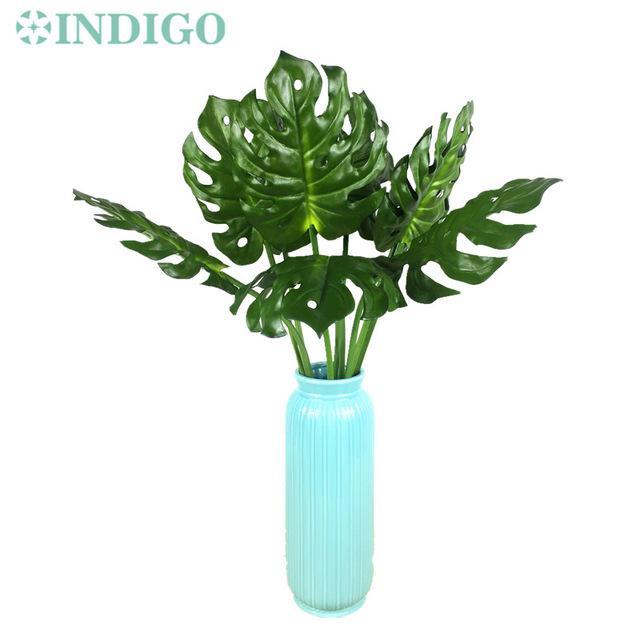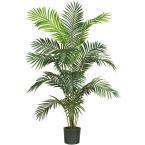The first image is the image on the left, the second image is the image on the right. For the images shown, is this caption "At least one vase is clear glass." true? Answer yes or no. No. The first image is the image on the left, the second image is the image on the right. Considering the images on both sides, is "One vase is tall, opaque and solid-colored with a ribbed surface, and the other vase is shorter and black in color." valid? Answer yes or no. Yes. 